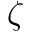Convert formula to latex. <formula><loc_0><loc_0><loc_500><loc_500>\zeta</formula> 